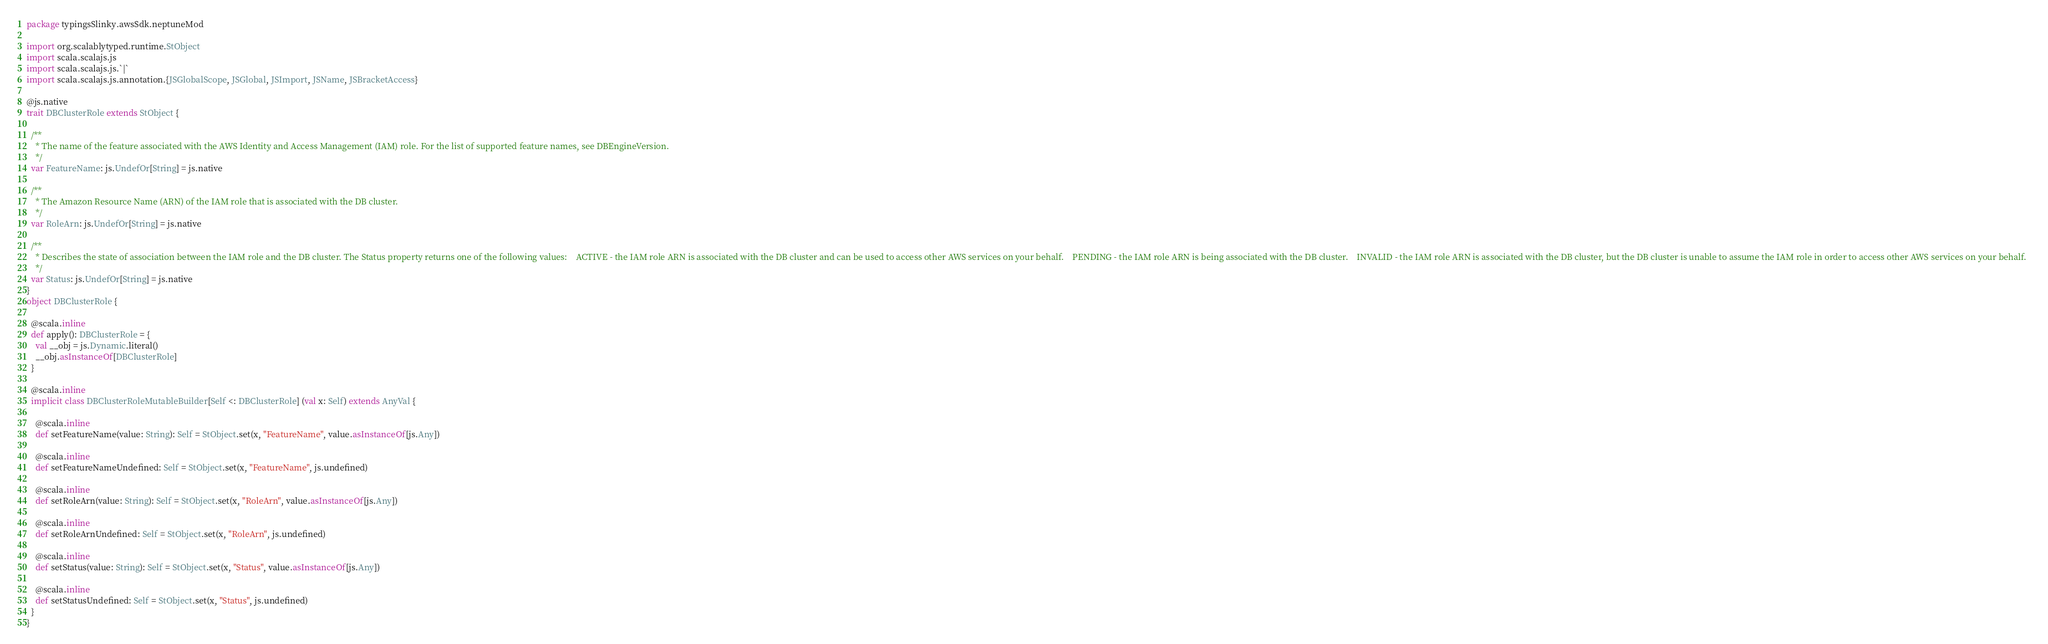<code> <loc_0><loc_0><loc_500><loc_500><_Scala_>package typingsSlinky.awsSdk.neptuneMod

import org.scalablytyped.runtime.StObject
import scala.scalajs.js
import scala.scalajs.js.`|`
import scala.scalajs.js.annotation.{JSGlobalScope, JSGlobal, JSImport, JSName, JSBracketAccess}

@js.native
trait DBClusterRole extends StObject {
  
  /**
    * The name of the feature associated with the AWS Identity and Access Management (IAM) role. For the list of supported feature names, see DBEngineVersion. 
    */
  var FeatureName: js.UndefOr[String] = js.native
  
  /**
    * The Amazon Resource Name (ARN) of the IAM role that is associated with the DB cluster.
    */
  var RoleArn: js.UndefOr[String] = js.native
  
  /**
    * Describes the state of association between the IAM role and the DB cluster. The Status property returns one of the following values:    ACTIVE - the IAM role ARN is associated with the DB cluster and can be used to access other AWS services on your behalf.    PENDING - the IAM role ARN is being associated with the DB cluster.    INVALID - the IAM role ARN is associated with the DB cluster, but the DB cluster is unable to assume the IAM role in order to access other AWS services on your behalf.  
    */
  var Status: js.UndefOr[String] = js.native
}
object DBClusterRole {
  
  @scala.inline
  def apply(): DBClusterRole = {
    val __obj = js.Dynamic.literal()
    __obj.asInstanceOf[DBClusterRole]
  }
  
  @scala.inline
  implicit class DBClusterRoleMutableBuilder[Self <: DBClusterRole] (val x: Self) extends AnyVal {
    
    @scala.inline
    def setFeatureName(value: String): Self = StObject.set(x, "FeatureName", value.asInstanceOf[js.Any])
    
    @scala.inline
    def setFeatureNameUndefined: Self = StObject.set(x, "FeatureName", js.undefined)
    
    @scala.inline
    def setRoleArn(value: String): Self = StObject.set(x, "RoleArn", value.asInstanceOf[js.Any])
    
    @scala.inline
    def setRoleArnUndefined: Self = StObject.set(x, "RoleArn", js.undefined)
    
    @scala.inline
    def setStatus(value: String): Self = StObject.set(x, "Status", value.asInstanceOf[js.Any])
    
    @scala.inline
    def setStatusUndefined: Self = StObject.set(x, "Status", js.undefined)
  }
}
</code> 